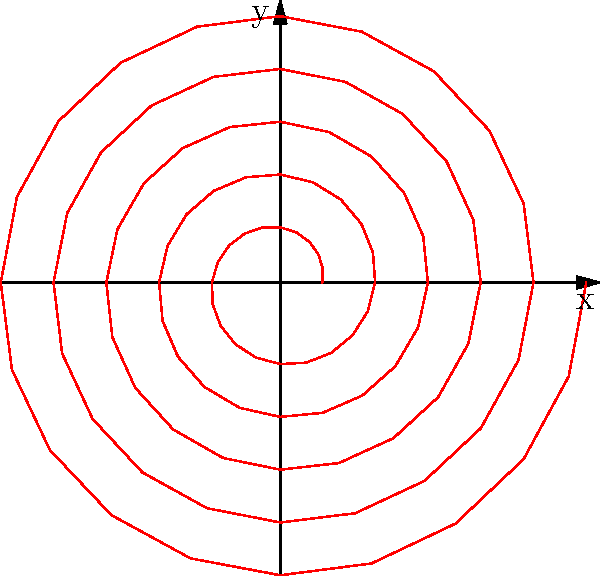In authenticating a suspected forgery of a spiral pattern artwork, you've plotted the spiral using polar coordinates. The equation of the spiral is given by $r = 0.1 + 0.02\theta$. What is the rate of change of the radius with respect to the angle $\theta$, and how might this information be useful in determining the authenticity of the artwork? To solve this problem, we'll follow these steps:

1) The general equation of the spiral is given as $r = 0.1 + 0.02\theta$

2) To find the rate of change of the radius with respect to $\theta$, we need to differentiate $r$ with respect to $\theta$:

   $$\frac{dr}{d\theta} = \frac{d}{d\theta}(0.1 + 0.02\theta) = 0.02$$

3) This constant value of 0.02 indicates that the radius increases by 0.02 units for every radian increase in $\theta$. 

4) In the context of art authentication:
   - This constant rate of change suggests a very regular and precise spiral pattern.
   - Authentic hand-drawn spirals might show slight variations in this rate.
   - A perfectly constant rate could indicate the use of mechanical tools or digital generation, which might be a sign of forgery, especially if the original artist was known for freehand work.
   - However, some artists might intentionally use precise tools or techniques to achieve this regularity.

5) To use this information in authentication:
   - Compare this rate to known authentic works by the same artist.
   - Look for minute variations that might indicate human involvement.
   - Consider the artist's known techniques and tools.
   - Analyze how this regularity fits with the artist's style and the time period of the supposed creation.
Answer: 0.02 units/radian; constant rate suggests precision, potentially indicating mechanical creation or intentional technique, to be compared with artist's known style and authentic works. 